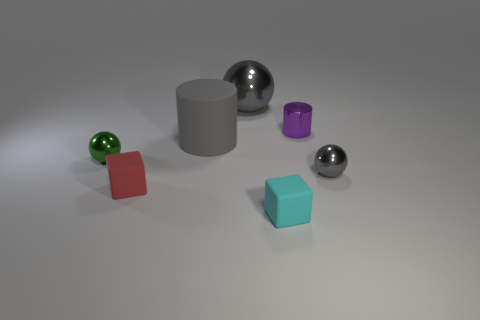Add 3 gray metal things. How many objects exist? 10 Subtract all gray spheres. How many spheres are left? 1 Subtract all spheres. How many objects are left? 4 Subtract all gray cylinders. How many cylinders are left? 1 Add 4 tiny blue matte balls. How many tiny blue matte balls exist? 4 Subtract 0 green cylinders. How many objects are left? 7 Subtract 1 cubes. How many cubes are left? 1 Subtract all cyan cubes. Subtract all cyan balls. How many cubes are left? 1 Subtract all gray cylinders. How many blue blocks are left? 0 Subtract all blocks. Subtract all tiny gray shiny spheres. How many objects are left? 4 